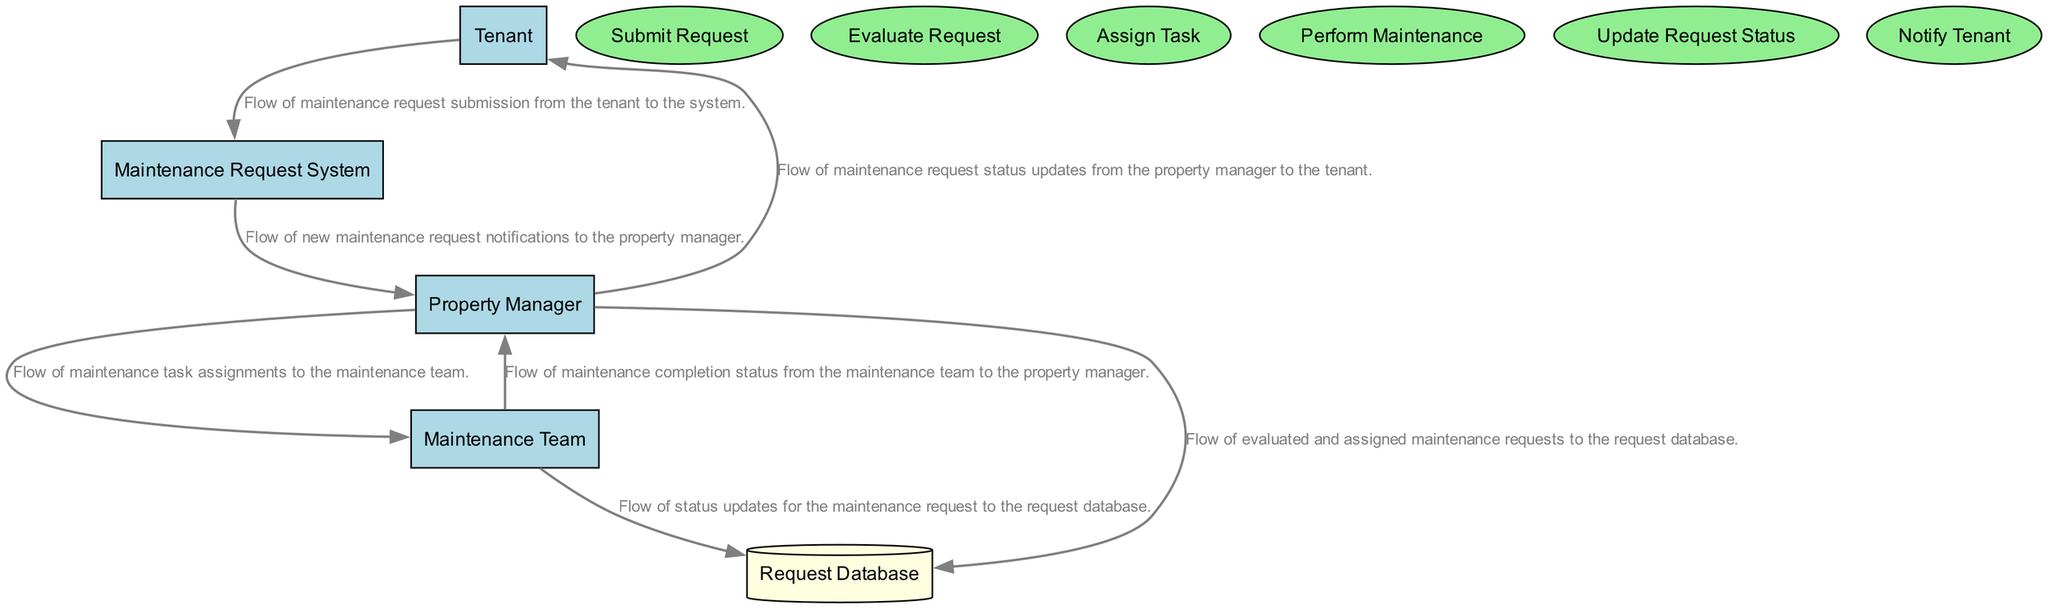What is the primary entity that submits maintenance requests? The diagram shows that the 'Tenant' is the individual or organization that submits maintenance requests through the system, indicated by the connection to the 'Submit Request' process.
Answer: Tenant How many main processes are involved in the workflow? There are a total of six main processes listed in the diagram, including 'Submit Request', 'Evaluate Request', 'Assign Task', 'Perform Maintenance', 'Update Request Status', and 'Notify Tenant'.
Answer: Six What action does the 'Property Manager' take after evaluating a maintenance request? According to the diagram, after evaluating the maintenance request, the 'Property Manager' assigns the task to the 'Maintenance Team', established by the flow leading to the 'Assign Task' process.
Answer: Assign Task Which entity receives notifications of new maintenance requests? The 'Property Manager' receives notifications from the 'Maintenance Request System' as indicated by the directional data flow labeled in the diagram.
Answer: Property Manager What type of storage is used to keep maintenance request data? The diagram identifies the 'Request Database' as the type of storage where all submitted maintenance requests and their status are stored, represented as a cylinder shape in the diagram.
Answer: Request Database What is the last step of the maintenance request workflow? The final step in the workflow is for the 'Property Manager' to notify the 'Tenant' about the status of their maintenance request after completion, which is shown as the last process in the flow.
Answer: Notify Tenant Describe the relationship between the 'Maintenance Team' and the 'Request Database'. The 'Maintenance Team' updates the status of the maintenance requests in the 'Request Database', as depicted by the flow indicating the updates made after maintenance tasks are performed.
Answer: Update Status How many entities are represented in the diagram? The diagram features four distinct entities, which are 'Tenant', 'Property Manager', 'Maintenance Team', and 'Maintenance Request System'.
Answer: Four What information is sent from the 'Maintenance Team' to the 'Property Manager' after maintenance completion? The information sent is the maintenance completion status, which is explicitly described in the diagram by the corresponding flow between these two components.
Answer: Maintenance Completion Status 